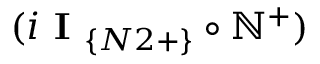<formula> <loc_0><loc_0><loc_500><loc_500>( i I _ { \{ N 2 + \} } \circ \mathbb { N } ^ { + } )</formula> 